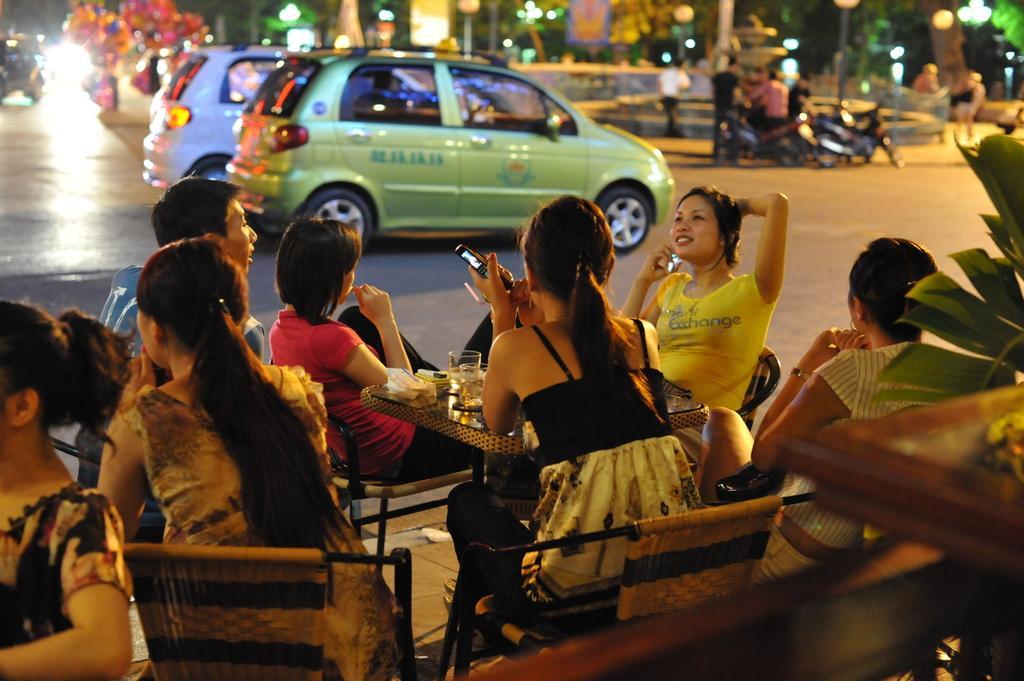Could you give a brief overview of what you see in this image? There are persons in different color dresses, sitting on chairs and there are some objects on a table. On the right side, there is a plant. In the background, there are vehicles on the road, there are persons, there are lights and there are trees. 